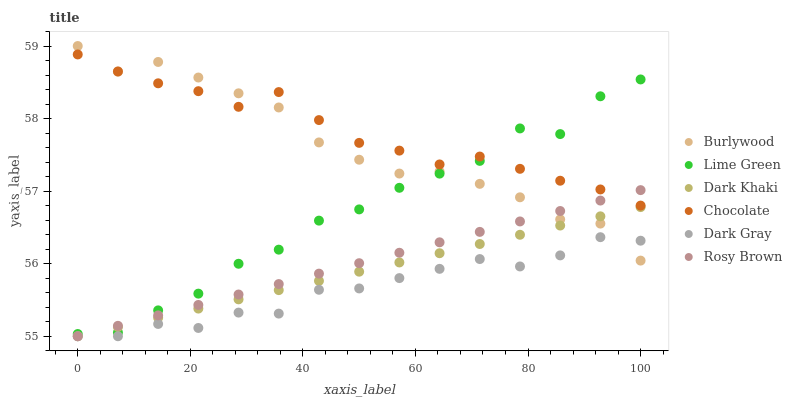Does Dark Gray have the minimum area under the curve?
Answer yes or no. Yes. Does Chocolate have the maximum area under the curve?
Answer yes or no. Yes. Does Burlywood have the minimum area under the curve?
Answer yes or no. No. Does Burlywood have the maximum area under the curve?
Answer yes or no. No. Is Dark Khaki the smoothest?
Answer yes or no. Yes. Is Lime Green the roughest?
Answer yes or no. Yes. Is Burlywood the smoothest?
Answer yes or no. No. Is Burlywood the roughest?
Answer yes or no. No. Does Dark Gray have the lowest value?
Answer yes or no. Yes. Does Burlywood have the lowest value?
Answer yes or no. No. Does Burlywood have the highest value?
Answer yes or no. Yes. Does Rosy Brown have the highest value?
Answer yes or no. No. Is Dark Gray less than Lime Green?
Answer yes or no. Yes. Is Chocolate greater than Dark Khaki?
Answer yes or no. Yes. Does Lime Green intersect Rosy Brown?
Answer yes or no. Yes. Is Lime Green less than Rosy Brown?
Answer yes or no. No. Is Lime Green greater than Rosy Brown?
Answer yes or no. No. Does Dark Gray intersect Lime Green?
Answer yes or no. No. 